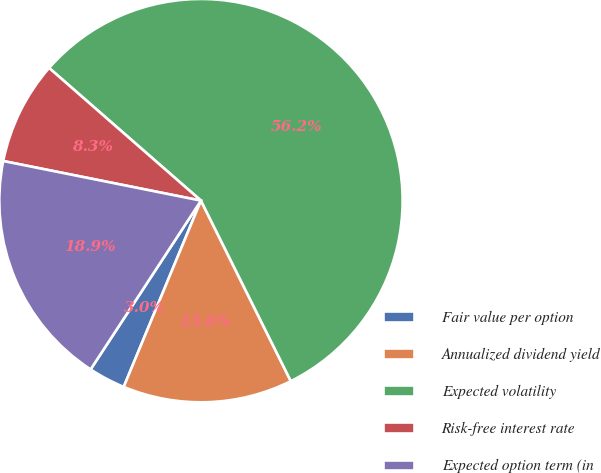Convert chart. <chart><loc_0><loc_0><loc_500><loc_500><pie_chart><fcel>Fair value per option<fcel>Annualized dividend yield<fcel>Expected volatility<fcel>Risk-free interest rate<fcel>Expected option term (in<nl><fcel>2.96%<fcel>13.61%<fcel>56.22%<fcel>8.28%<fcel>18.93%<nl></chart> 